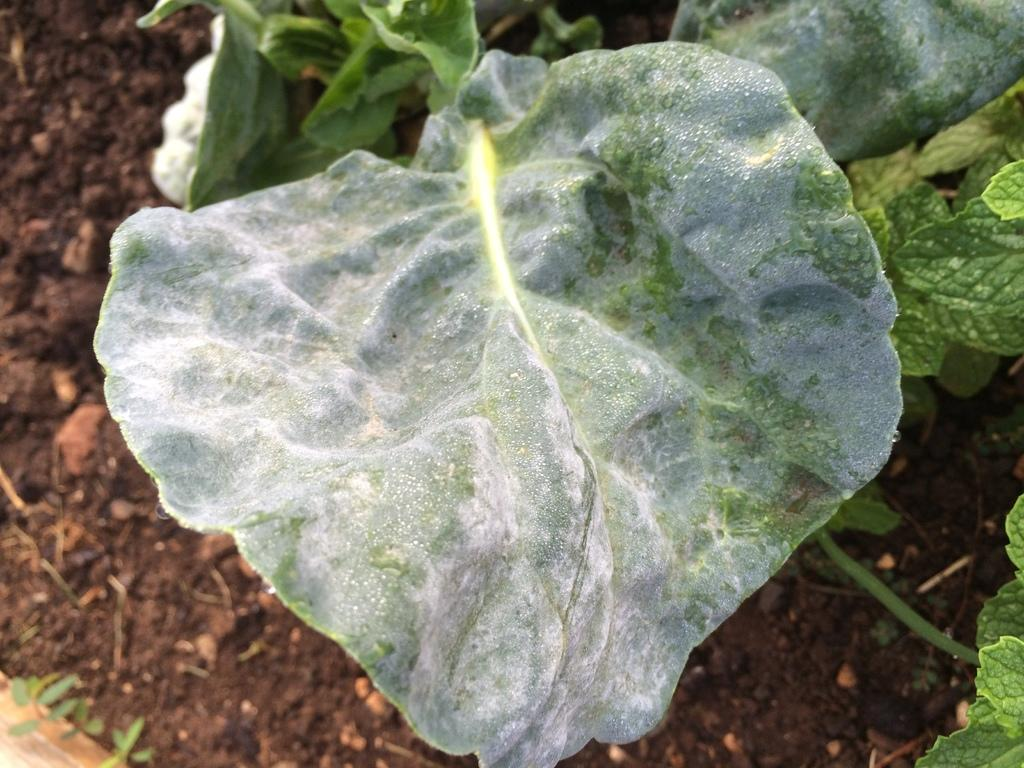What type of plant material can be seen in the image? There are leaves and stems in the image. What is the background of the image composed of? There is mud visible behind the leaves in the image. Where is the scarecrow located in the image? There is no scarecrow present in the image. What type of rod can be seen holding up the leaves in the image? There is no rod holding up the leaves in the image; the leaves are likely attached to stems. 